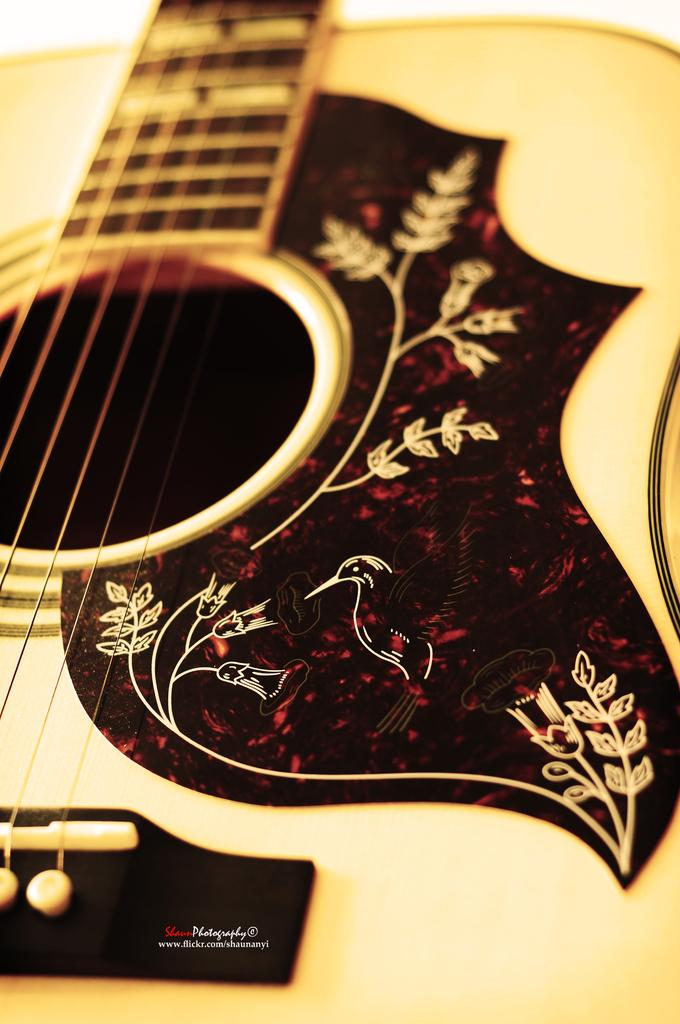What musical instrument is present in the image? There is a guitar in the image. Can you describe the guitar in the image? The image only shows a guitar, without any specific details about its appearance or condition. What might someone be doing with the guitar in the image? It is not possible to determine what someone might be doing with the guitar from the image alone. Where is the faucet located in the image? There is no faucet present in the image; it only features a guitar. 